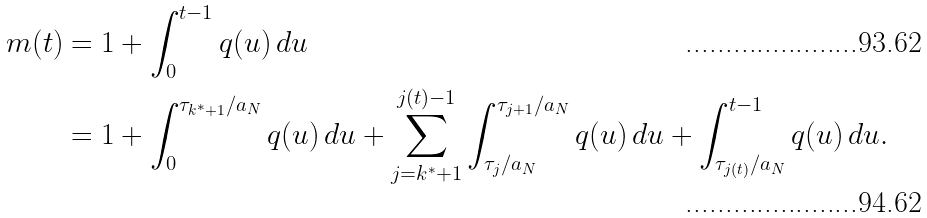Convert formula to latex. <formula><loc_0><loc_0><loc_500><loc_500>m ( t ) & = 1 + \int _ { 0 } ^ { t - 1 } q ( u ) \, d u \\ & = 1 + \int _ { 0 } ^ { \tau _ { k ^ { * } + 1 } / a _ { N } } q ( u ) \, d u + \sum _ { j = k ^ { * } + 1 } ^ { j ( t ) - 1 } \int _ { \tau _ { j } / a _ { N } } ^ { \tau _ { j + 1 } / a _ { N } } q ( u ) \, d u + \int _ { \tau _ { j ( t ) } / a _ { N } } ^ { t - 1 } q ( u ) \, d u .</formula> 